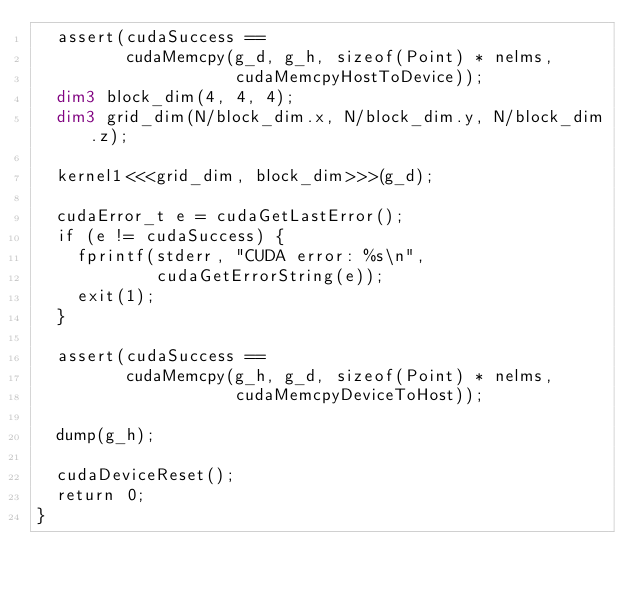<code> <loc_0><loc_0><loc_500><loc_500><_Cuda_>  assert(cudaSuccess ==
         cudaMemcpy(g_d, g_h, sizeof(Point) * nelms,
                    cudaMemcpyHostToDevice));
  dim3 block_dim(4, 4, 4);
  dim3 grid_dim(N/block_dim.x, N/block_dim.y, N/block_dim.z);

  kernel1<<<grid_dim, block_dim>>>(g_d);
  
  cudaError_t e = cudaGetLastError();
  if (e != cudaSuccess) {
    fprintf(stderr, "CUDA error: %s\n",
            cudaGetErrorString(e));
    exit(1);
  }

  assert(cudaSuccess ==
         cudaMemcpy(g_h, g_d, sizeof(Point) * nelms,
                    cudaMemcpyDeviceToHost));

  dump(g_h);

  cudaDeviceReset();
  return 0;
}

</code> 